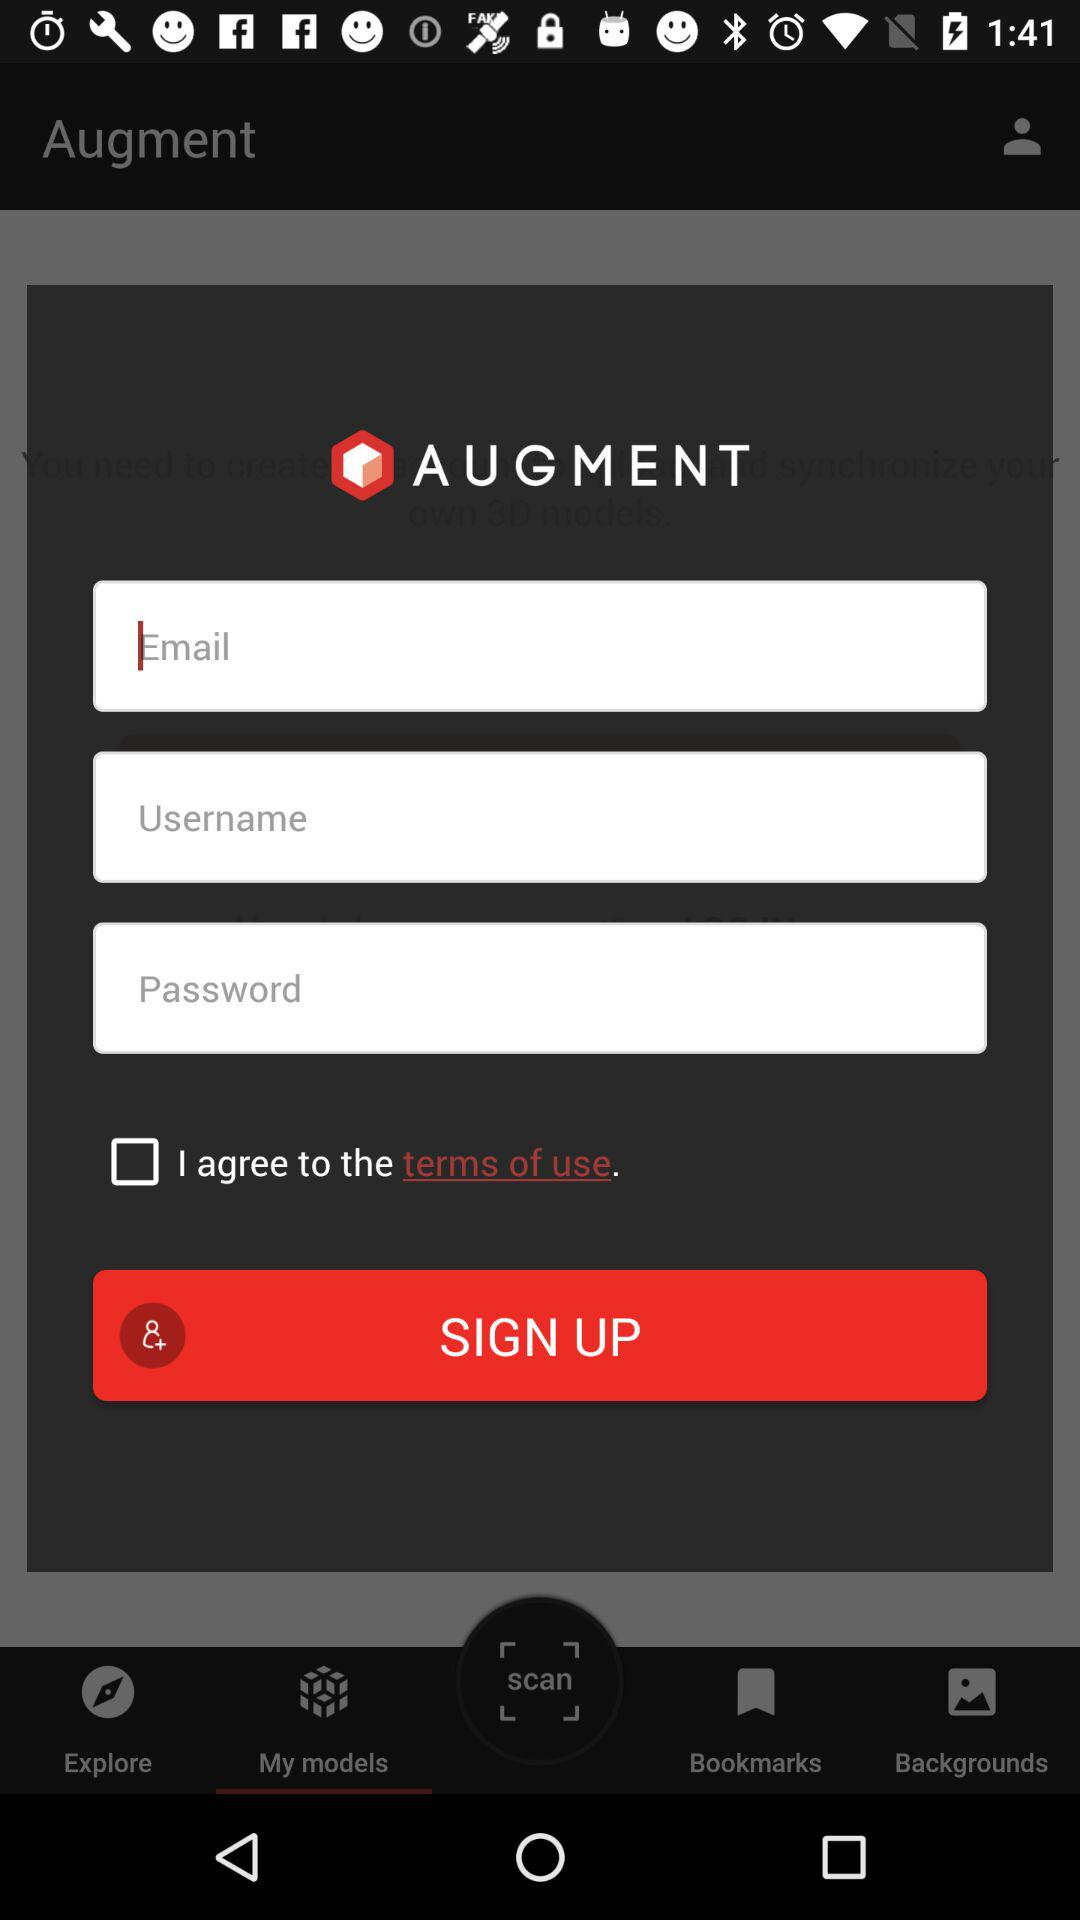How many more text inputs are there than checkboxes on this page?
Answer the question using a single word or phrase. 2 